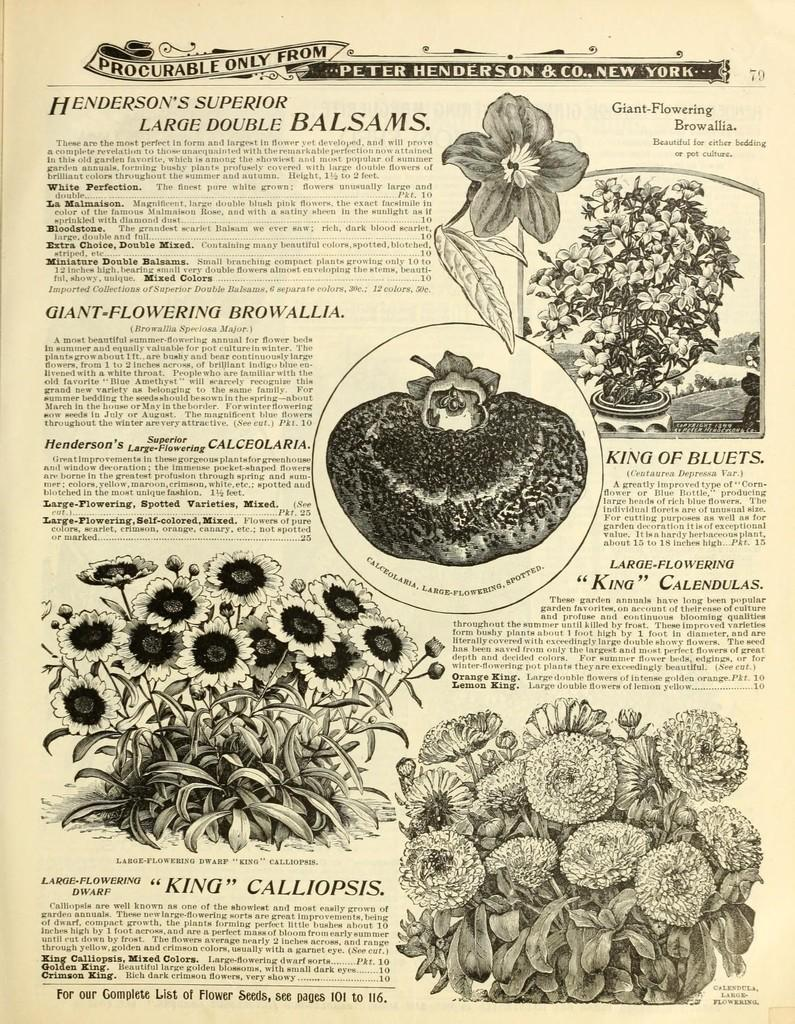What type of visual is the image? The image appears to be a poster. What can be seen on the poster? There are pictures on the poster. What else is featured on the poster besides the images? There is text on the poster. How many pigs are present on the poster? There is no mention of pigs in the provided facts, so it cannot be determined if any are present on the poster. What color are the socks depicted on the poster? There is no mention of socks in the provided facts, so it cannot be determined if any are present on the poster. 